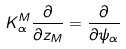Convert formula to latex. <formula><loc_0><loc_0><loc_500><loc_500>K _ { \alpha } ^ { M } \frac { \partial } { \partial z _ { M } } = \frac { \partial } { \partial \psi _ { \alpha } }</formula> 